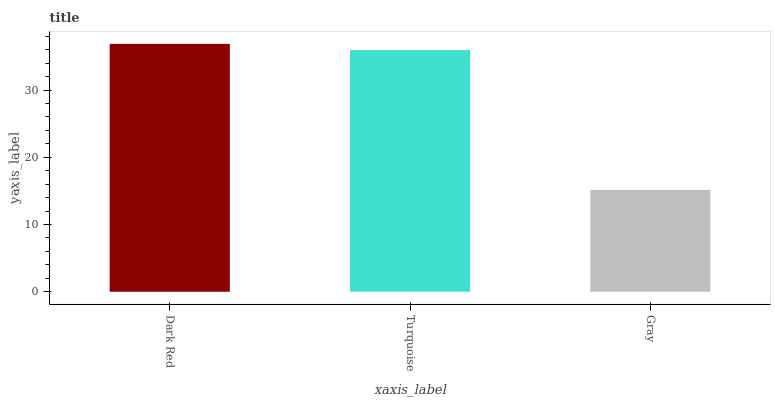Is Gray the minimum?
Answer yes or no. Yes. Is Dark Red the maximum?
Answer yes or no. Yes. Is Turquoise the minimum?
Answer yes or no. No. Is Turquoise the maximum?
Answer yes or no. No. Is Dark Red greater than Turquoise?
Answer yes or no. Yes. Is Turquoise less than Dark Red?
Answer yes or no. Yes. Is Turquoise greater than Dark Red?
Answer yes or no. No. Is Dark Red less than Turquoise?
Answer yes or no. No. Is Turquoise the high median?
Answer yes or no. Yes. Is Turquoise the low median?
Answer yes or no. Yes. Is Gray the high median?
Answer yes or no. No. Is Gray the low median?
Answer yes or no. No. 